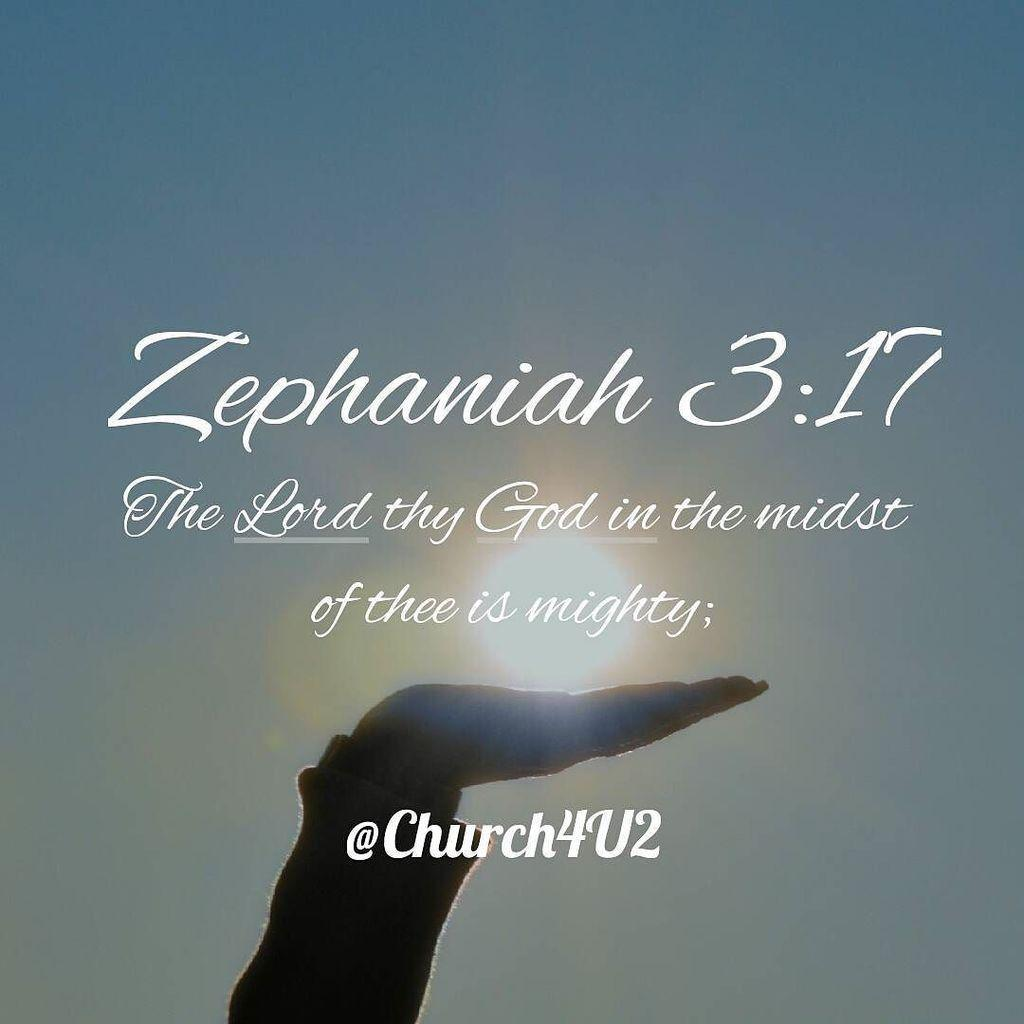What type of editing has been done to the image? The image is edited, but the specific type of editing is not mentioned in the facts. What can be seen in the image besides the editing? There is a person's hand and text written on the image. What is visible in the background of the image? The sun is visible in the sky in the background of the image. How does the hose affect the person's sleep in the image? There is no hose present in the image, so it cannot affect the person's sleep. 